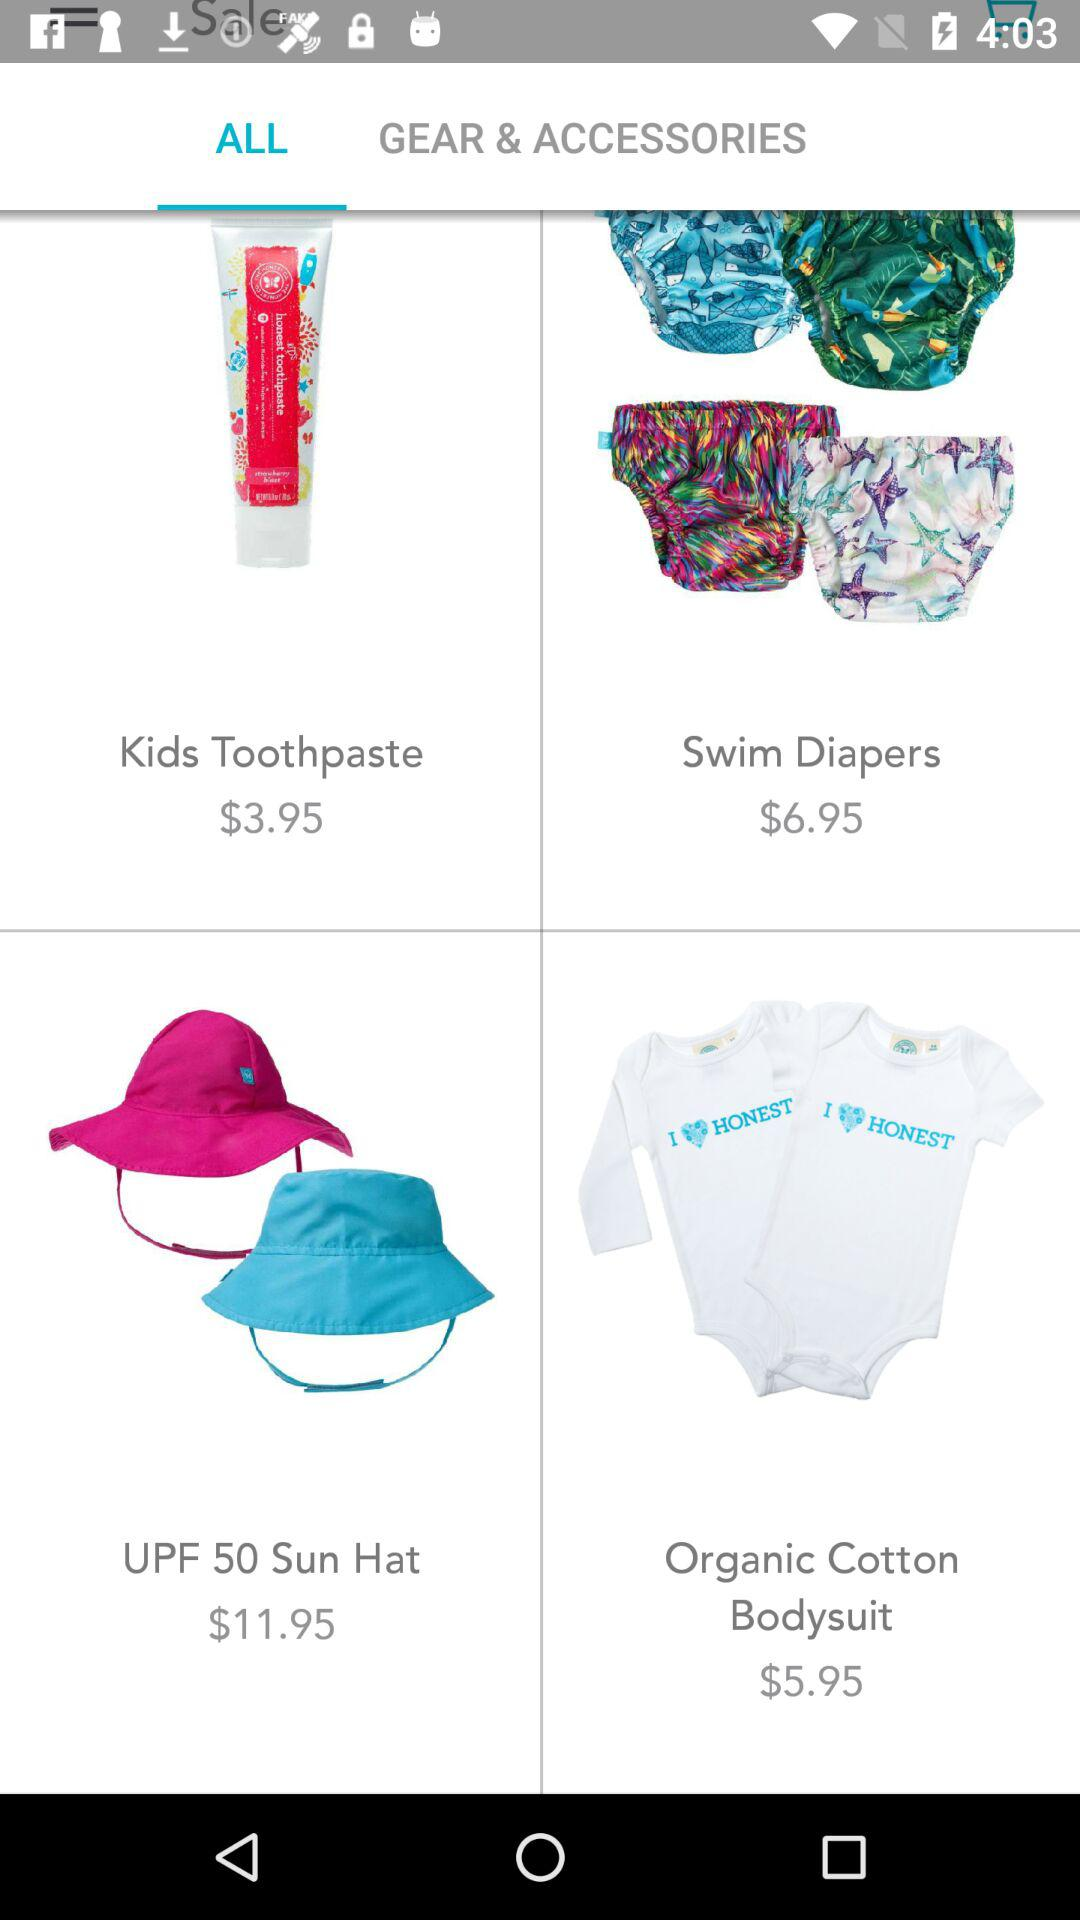What is the price of the organic cotton bodysuit? The price is $5.95. 